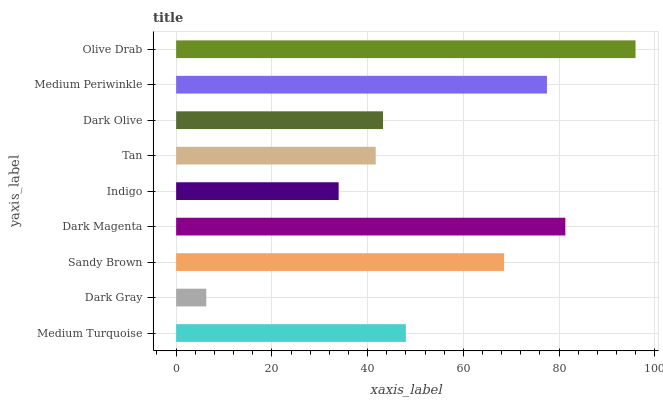Is Dark Gray the minimum?
Answer yes or no. Yes. Is Olive Drab the maximum?
Answer yes or no. Yes. Is Sandy Brown the minimum?
Answer yes or no. No. Is Sandy Brown the maximum?
Answer yes or no. No. Is Sandy Brown greater than Dark Gray?
Answer yes or no. Yes. Is Dark Gray less than Sandy Brown?
Answer yes or no. Yes. Is Dark Gray greater than Sandy Brown?
Answer yes or no. No. Is Sandy Brown less than Dark Gray?
Answer yes or no. No. Is Medium Turquoise the high median?
Answer yes or no. Yes. Is Medium Turquoise the low median?
Answer yes or no. Yes. Is Olive Drab the high median?
Answer yes or no. No. Is Tan the low median?
Answer yes or no. No. 